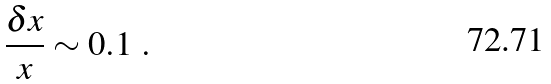<formula> <loc_0><loc_0><loc_500><loc_500>\frac { \delta x } { x } \sim 0 . 1 \ .</formula> 